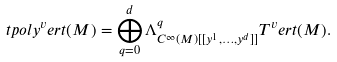<formula> <loc_0><loc_0><loc_500><loc_500>\ t p o l y ^ { v } e r t ( M ) = \bigoplus _ { q = 0 } ^ { d } \Lambda ^ { q } _ { C ^ { \infty } ( M ) [ [ y ^ { 1 } , \dots , y ^ { d } ] ] } T ^ { v } e r t ( M ) .</formula> 